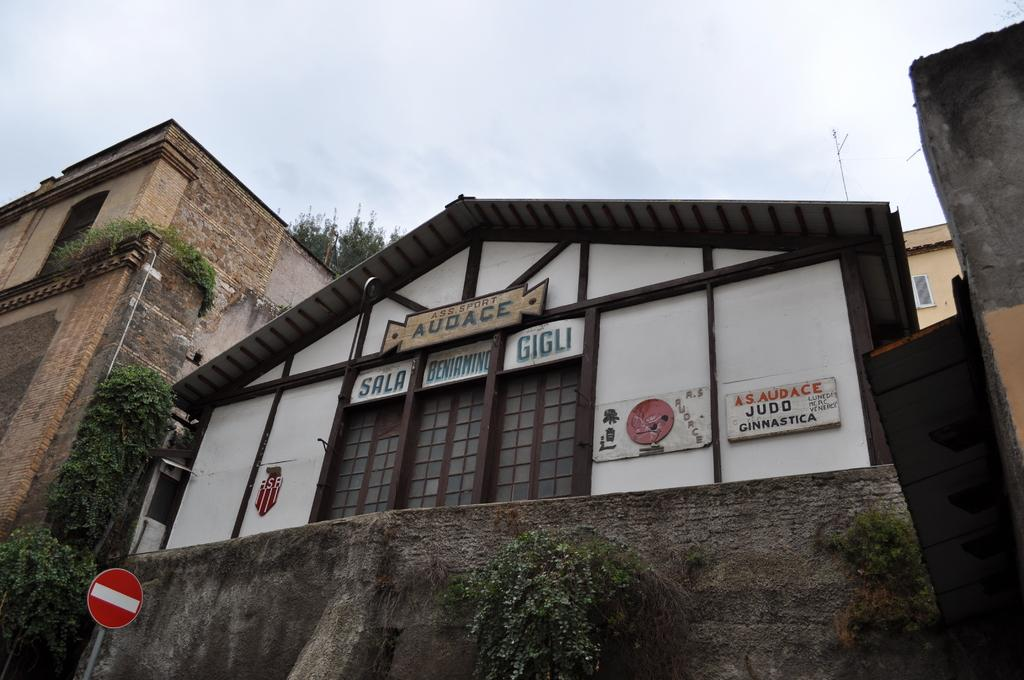What type of structures can be seen in the image? There are houses in the image. What other elements are present in the image besides the houses? There are plants, a signboard, and boards with text written in the image. What can be seen in the sky in the image? The sky is visible in the image. What type of appliance is being used by the plants in the image? There are no appliances present in the image; the plants are not using any devices. 